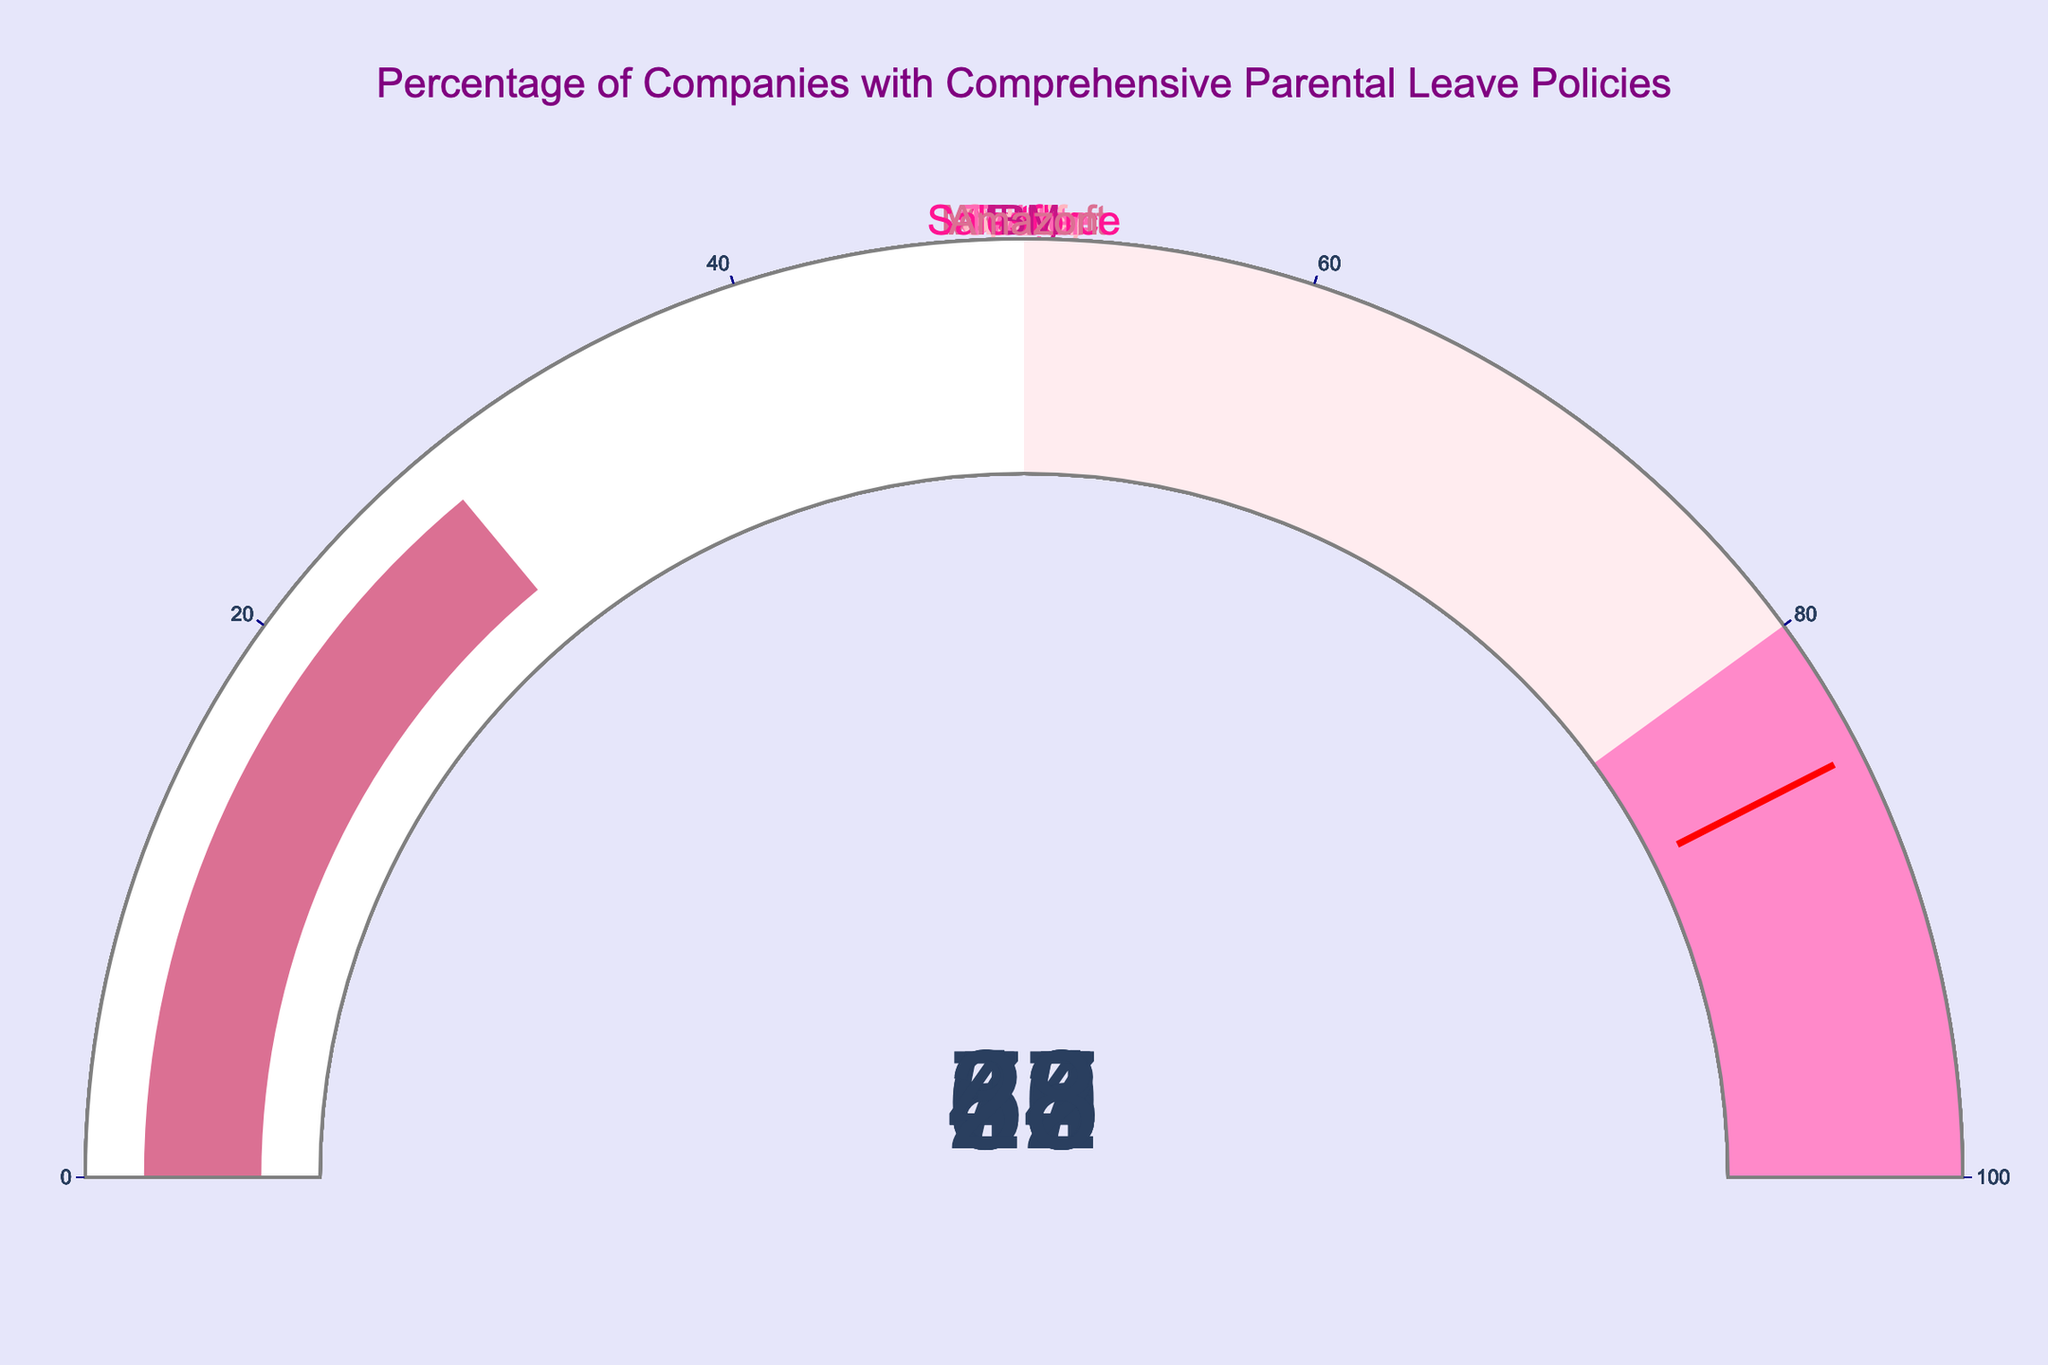How many companies have comprehensive parental leave policies? By counting all the gauge charts displayed in the figure, we can determine the number of companies.
Answer: 10 Which company has the highest percentage of parental leave policies? By comparing the values indicated on each gauge, we see that Google has the highest percentage at 84%.
Answer: Google Is the percentage of comprehensive parental leave policies at Amazon above or below 30%? The gauge for Amazon shows a percentage of 28, which is below 30%.
Answer: Below What's the difference in parental leave policy percentages between Spotify and Adobe? Spotify has a percentage of 55, while Adobe has 48. The difference is calculated by subtracting 48 from 55.
Answer: 7 What is the average percentage of comprehensive parental leave policies among Google, Netflix, and Etsy? Add the percentages for Google (84), Netflix (75), and Etsy (68), then divide by 3. (84 + 75 + 68) / 3 = 75.67
Answer: 75.67 Which two companies have the smallest difference in their parental leave policy percentages? By comparing the differences between the percentages of all pairs, IBM and Amazon have the smallest difference of 4% (IBM at 32% and Amazon at 28%).
Answer: IBM and Amazon Are there any companies with parental leave policy percentages in the range of 40% to 50%? Checking each gauge, only Twitter and Adobe fall into this range with 42% and 48% respectively.
Answer: Yes What's the combined percentage of parental leave policies for Salesforce and IBM? Add the percentages for Salesforce (37) and IBM (32). 37 + 32 = 69
Answer: 69 Compare the parental leave policy percentages and determine how many companies have policies exceeding 50%. By examining each gauge, Google, Netflix, Etsy, Microsoft, and Spotify exceed 50%. The count is 5 companies.
Answer: 5 What is the title of the figure? The figure's title is displayed prominently at the top: "Percentage of Companies with Comprehensive Parental Leave Policies".
Answer: Percentage of Companies with Comprehensive Parental Leave Policies 